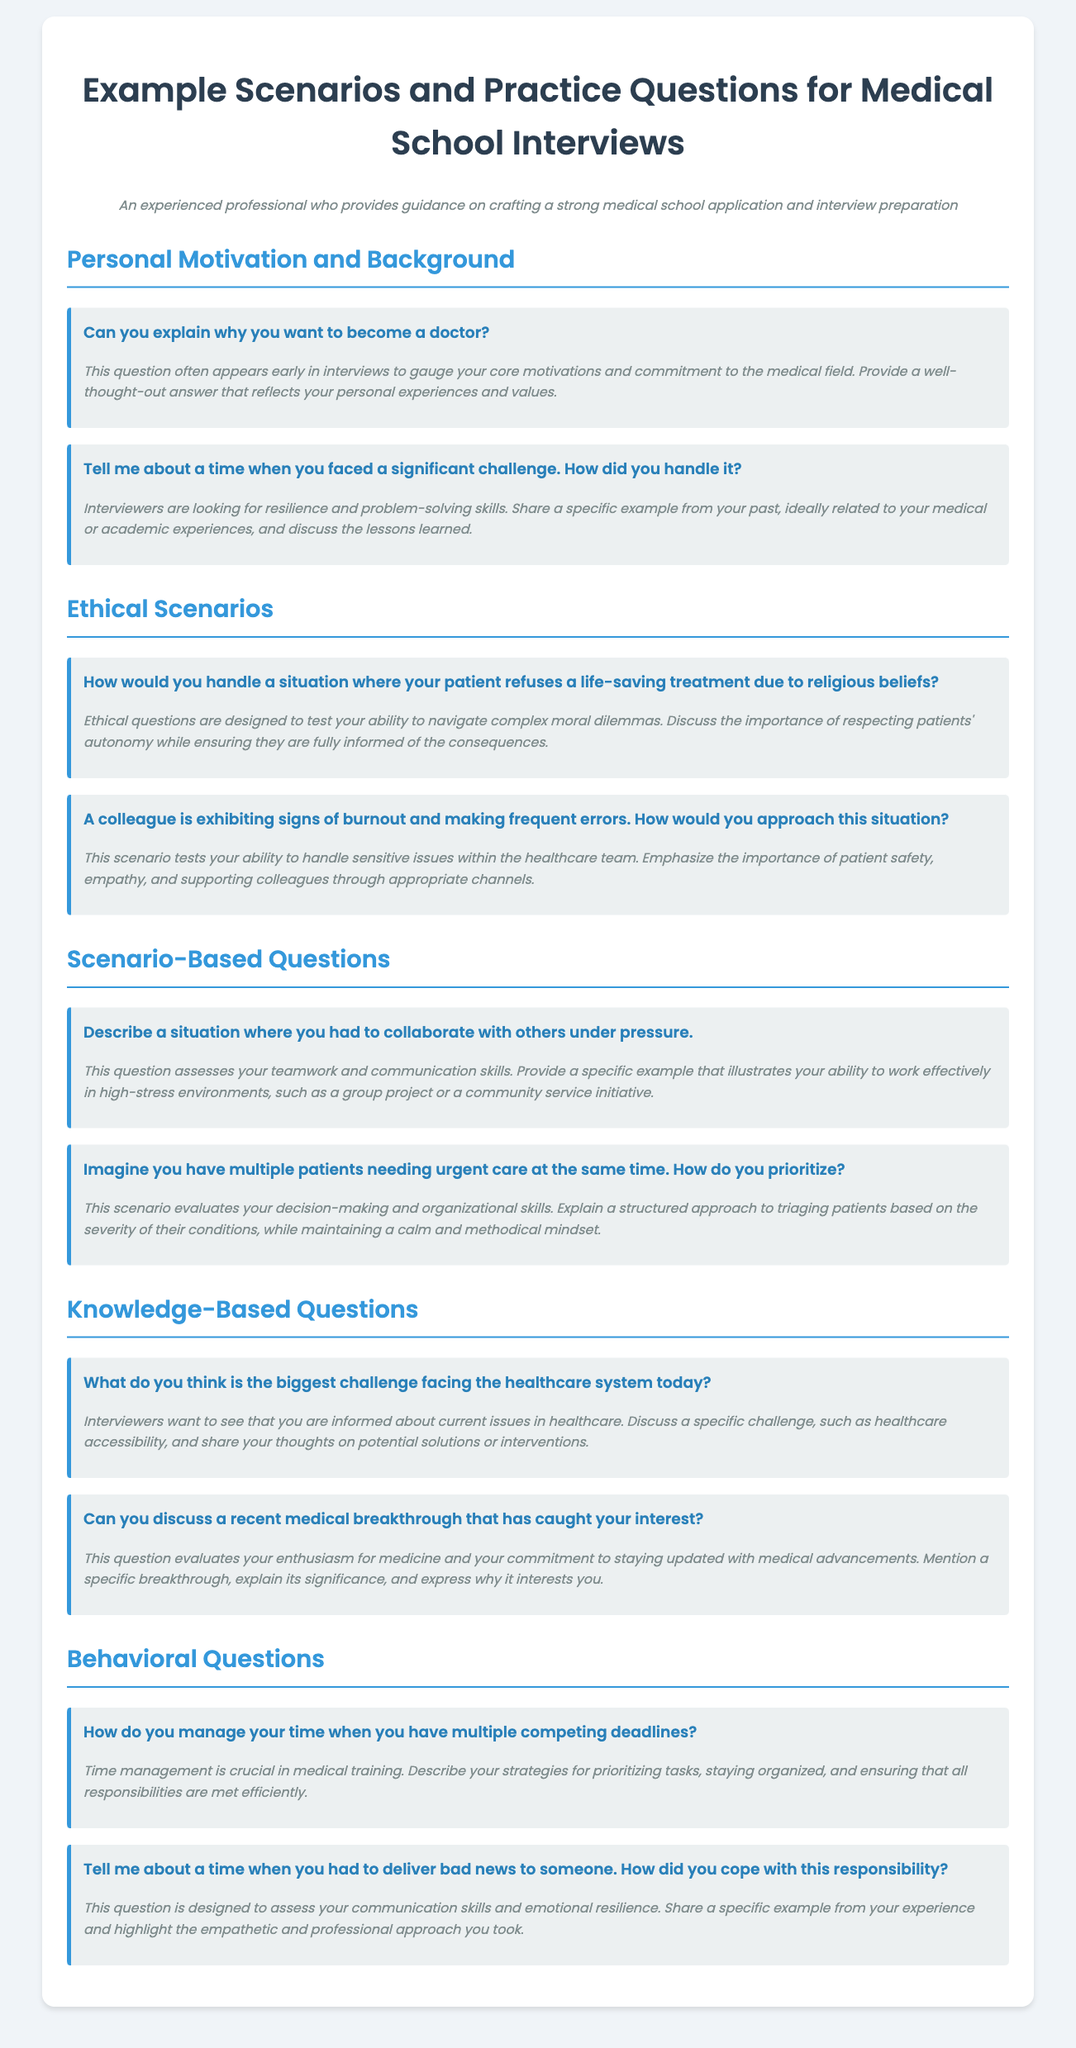what is the title of the document? The title of the document is indicated prominently at the top of the page within the <h1> tag.
Answer: Example Scenarios and Practice Questions for Medical School Interviews how many sections are there in the document? The number of sections can be counted by observing the main headings present in the document, which are defined by the <h2> tags.
Answer: 5 what is a common question asked early in interviews? This specific question is listed prominently in the document under the Personal Motivation and Background section.
Answer: Can you explain why you want to become a doctor? what topic does the scenario about patient treatment refusal address? This question relates to the section that discusses ethical dilemmas in medical practice and is found under Ethical Scenarios.
Answer: Ethical dilemmas what is the focus of the knowledge-based questions section? This can be derived from the heading and the content, which centers around current issues and medical advancements in healthcare.
Answer: Current issues in healthcare how does the document categorize practice questions? The organization of the document shows distinct categories for practice questions, primarily focused on different aspects of medical interviews.
Answer: By sections (Personal Motivation, Ethical Scenarios, etc.) which skill is evaluated through the time management question? The question under Behavioral Questions aims to assess a specific skill critical in medical training and practice.
Answer: Time management what type of question is about delivering bad news? This question fits into a category that explores specific competencies required for effective communication and emotional resilience.
Answer: Behavioral question 